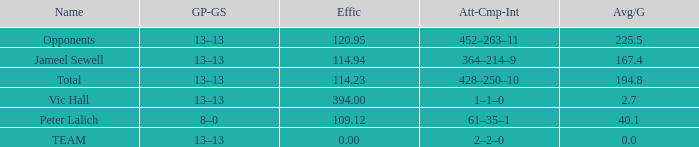Avg/G smaller than 225.5, and a GP-GS of 8–0 has what name? Peter Lalich. 